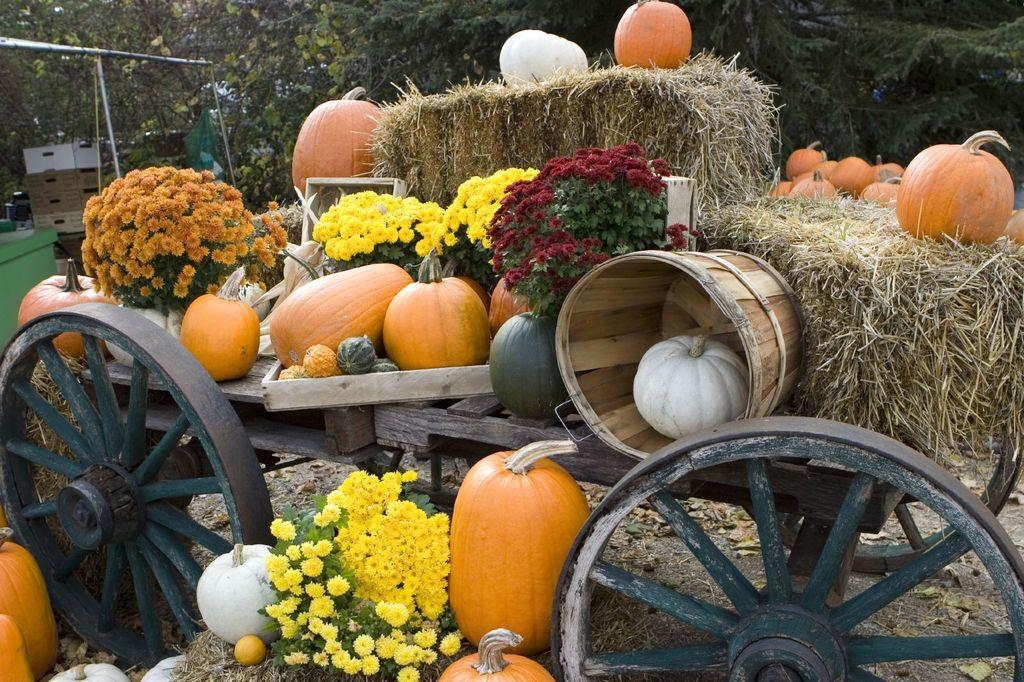What types of flowers can be seen in the image? There are different colors of flowers in the image. What is the object with wheels in the image? There is a cart in the image. What is the texture of the ground in the image? There is dry grass in the image. What can be seen in the distance in the image? There are trees in the background of the image. Where is the grass located in the image? There is grass on the left side of the image. What structure is located on the left side of the image? There is a building on the left side of the image. What type of juice is being served from the cart in the image? There is no cart serving juice in the image; it is a cart with wheels, but no mention of juice. What type of clover can be seen growing in the grass on the left side of the image? There is no clover visible in the image; only flowers, dry grass, and a building are present on the left side. 